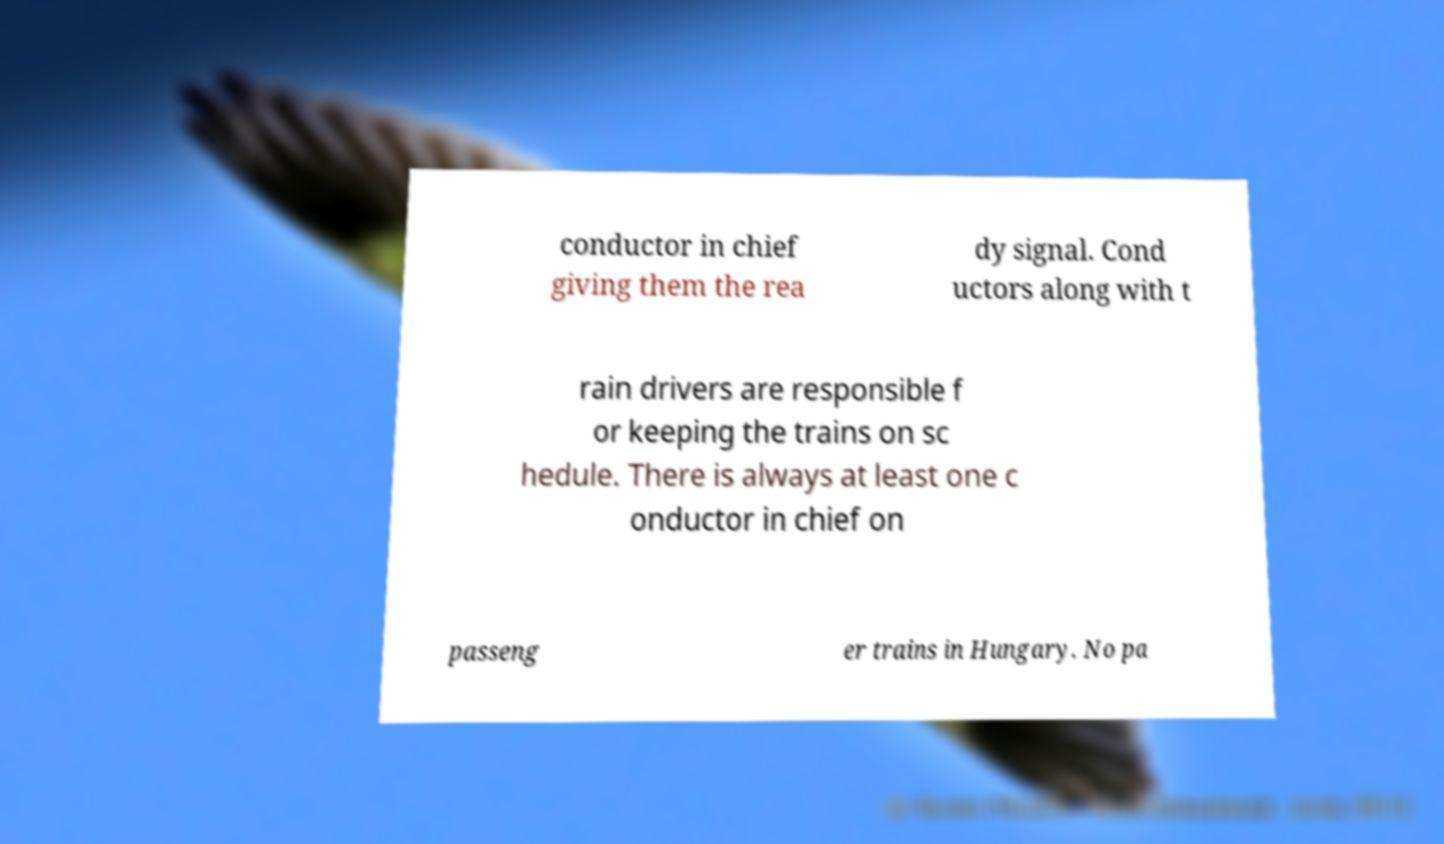I need the written content from this picture converted into text. Can you do that? conductor in chief giving them the rea dy signal. Cond uctors along with t rain drivers are responsible f or keeping the trains on sc hedule. There is always at least one c onductor in chief on passeng er trains in Hungary. No pa 